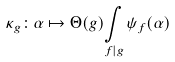<formula> <loc_0><loc_0><loc_500><loc_500>\kappa _ { g } \colon \alpha \mapsto \Theta ( g ) \underset { f | g } { \int } \, \psi _ { f } ( \alpha )</formula> 